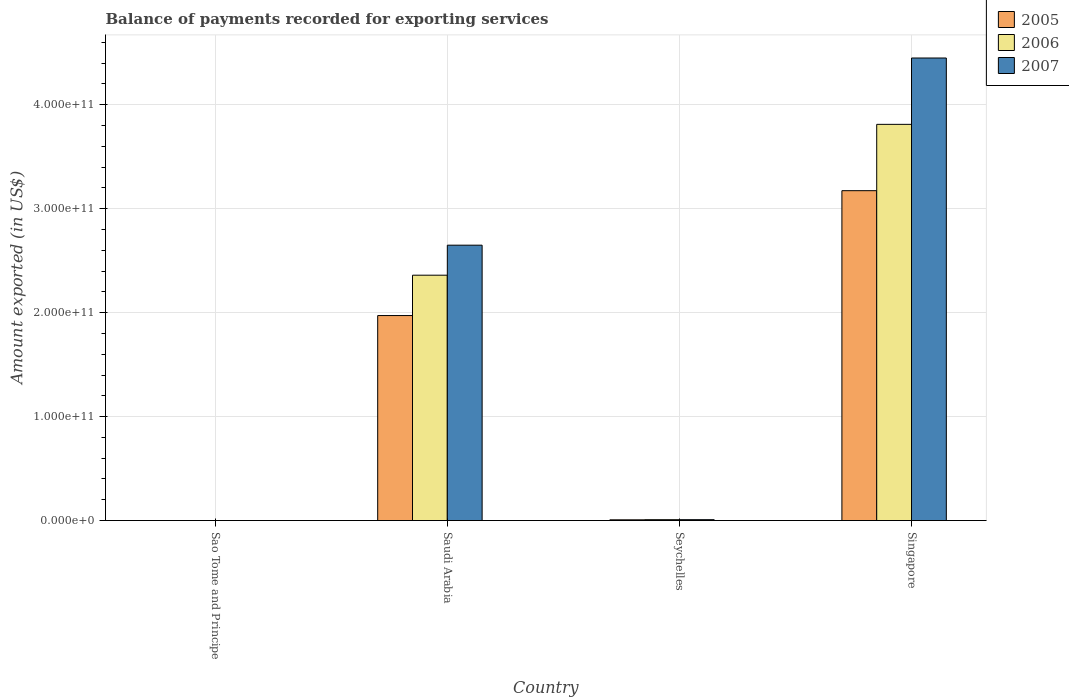How many groups of bars are there?
Give a very brief answer. 4. Are the number of bars per tick equal to the number of legend labels?
Your response must be concise. Yes. How many bars are there on the 1st tick from the left?
Offer a terse response. 3. How many bars are there on the 2nd tick from the right?
Your answer should be very brief. 3. What is the label of the 1st group of bars from the left?
Offer a terse response. Sao Tome and Principe. In how many cases, is the number of bars for a given country not equal to the number of legend labels?
Provide a short and direct response. 0. What is the amount exported in 2006 in Saudi Arabia?
Ensure brevity in your answer.  2.36e+11. Across all countries, what is the maximum amount exported in 2007?
Ensure brevity in your answer.  4.45e+11. Across all countries, what is the minimum amount exported in 2007?
Provide a short and direct response. 2.03e+07. In which country was the amount exported in 2007 maximum?
Ensure brevity in your answer.  Singapore. In which country was the amount exported in 2005 minimum?
Keep it short and to the point. Sao Tome and Principe. What is the total amount exported in 2005 in the graph?
Offer a very short reply. 5.15e+11. What is the difference between the amount exported in 2007 in Sao Tome and Principe and that in Singapore?
Your answer should be very brief. -4.45e+11. What is the difference between the amount exported in 2006 in Seychelles and the amount exported in 2005 in Saudi Arabia?
Your answer should be very brief. -1.96e+11. What is the average amount exported in 2006 per country?
Give a very brief answer. 1.54e+11. What is the difference between the amount exported of/in 2006 and amount exported of/in 2007 in Singapore?
Make the answer very short. -6.38e+1. In how many countries, is the amount exported in 2006 greater than 60000000000 US$?
Make the answer very short. 2. What is the ratio of the amount exported in 2006 in Saudi Arabia to that in Seychelles?
Offer a terse response. 274.2. What is the difference between the highest and the second highest amount exported in 2005?
Your answer should be very brief. 1.20e+11. What is the difference between the highest and the lowest amount exported in 2005?
Your response must be concise. 3.17e+11. Is the sum of the amount exported in 2007 in Sao Tome and Principe and Seychelles greater than the maximum amount exported in 2005 across all countries?
Your answer should be compact. No. Is it the case that in every country, the sum of the amount exported in 2006 and amount exported in 2007 is greater than the amount exported in 2005?
Ensure brevity in your answer.  Yes. How many bars are there?
Keep it short and to the point. 12. How many countries are there in the graph?
Give a very brief answer. 4. What is the difference between two consecutive major ticks on the Y-axis?
Keep it short and to the point. 1.00e+11. Does the graph contain any zero values?
Give a very brief answer. No. Does the graph contain grids?
Make the answer very short. Yes. What is the title of the graph?
Your answer should be compact. Balance of payments recorded for exporting services. Does "1986" appear as one of the legend labels in the graph?
Your answer should be very brief. No. What is the label or title of the X-axis?
Offer a very short reply. Country. What is the label or title of the Y-axis?
Offer a terse response. Amount exported (in US$). What is the Amount exported (in US$) of 2005 in Sao Tome and Principe?
Your response must be concise. 1.79e+07. What is the Amount exported (in US$) of 2006 in Sao Tome and Principe?
Your answer should be very brief. 2.23e+07. What is the Amount exported (in US$) in 2007 in Sao Tome and Principe?
Ensure brevity in your answer.  2.03e+07. What is the Amount exported (in US$) of 2005 in Saudi Arabia?
Provide a succinct answer. 1.97e+11. What is the Amount exported (in US$) of 2006 in Saudi Arabia?
Offer a terse response. 2.36e+11. What is the Amount exported (in US$) of 2007 in Saudi Arabia?
Your answer should be very brief. 2.65e+11. What is the Amount exported (in US$) in 2005 in Seychelles?
Provide a short and direct response. 7.29e+08. What is the Amount exported (in US$) in 2006 in Seychelles?
Ensure brevity in your answer.  8.61e+08. What is the Amount exported (in US$) in 2007 in Seychelles?
Your answer should be very brief. 8.57e+08. What is the Amount exported (in US$) of 2005 in Singapore?
Provide a short and direct response. 3.17e+11. What is the Amount exported (in US$) in 2006 in Singapore?
Your response must be concise. 3.81e+11. What is the Amount exported (in US$) of 2007 in Singapore?
Your answer should be very brief. 4.45e+11. Across all countries, what is the maximum Amount exported (in US$) in 2005?
Provide a succinct answer. 3.17e+11. Across all countries, what is the maximum Amount exported (in US$) in 2006?
Ensure brevity in your answer.  3.81e+11. Across all countries, what is the maximum Amount exported (in US$) of 2007?
Provide a short and direct response. 4.45e+11. Across all countries, what is the minimum Amount exported (in US$) in 2005?
Offer a terse response. 1.79e+07. Across all countries, what is the minimum Amount exported (in US$) of 2006?
Offer a very short reply. 2.23e+07. Across all countries, what is the minimum Amount exported (in US$) in 2007?
Give a very brief answer. 2.03e+07. What is the total Amount exported (in US$) in 2005 in the graph?
Your response must be concise. 5.15e+11. What is the total Amount exported (in US$) in 2006 in the graph?
Your answer should be compact. 6.18e+11. What is the total Amount exported (in US$) of 2007 in the graph?
Your answer should be very brief. 7.11e+11. What is the difference between the Amount exported (in US$) in 2005 in Sao Tome and Principe and that in Saudi Arabia?
Give a very brief answer. -1.97e+11. What is the difference between the Amount exported (in US$) of 2006 in Sao Tome and Principe and that in Saudi Arabia?
Make the answer very short. -2.36e+11. What is the difference between the Amount exported (in US$) in 2007 in Sao Tome and Principe and that in Saudi Arabia?
Your answer should be very brief. -2.65e+11. What is the difference between the Amount exported (in US$) of 2005 in Sao Tome and Principe and that in Seychelles?
Your answer should be compact. -7.12e+08. What is the difference between the Amount exported (in US$) of 2006 in Sao Tome and Principe and that in Seychelles?
Keep it short and to the point. -8.38e+08. What is the difference between the Amount exported (in US$) in 2007 in Sao Tome and Principe and that in Seychelles?
Provide a succinct answer. -8.37e+08. What is the difference between the Amount exported (in US$) of 2005 in Sao Tome and Principe and that in Singapore?
Provide a short and direct response. -3.17e+11. What is the difference between the Amount exported (in US$) in 2006 in Sao Tome and Principe and that in Singapore?
Keep it short and to the point. -3.81e+11. What is the difference between the Amount exported (in US$) of 2007 in Sao Tome and Principe and that in Singapore?
Provide a short and direct response. -4.45e+11. What is the difference between the Amount exported (in US$) of 2005 in Saudi Arabia and that in Seychelles?
Ensure brevity in your answer.  1.96e+11. What is the difference between the Amount exported (in US$) of 2006 in Saudi Arabia and that in Seychelles?
Offer a terse response. 2.35e+11. What is the difference between the Amount exported (in US$) in 2007 in Saudi Arabia and that in Seychelles?
Your answer should be compact. 2.64e+11. What is the difference between the Amount exported (in US$) of 2005 in Saudi Arabia and that in Singapore?
Your answer should be very brief. -1.20e+11. What is the difference between the Amount exported (in US$) of 2006 in Saudi Arabia and that in Singapore?
Keep it short and to the point. -1.45e+11. What is the difference between the Amount exported (in US$) in 2007 in Saudi Arabia and that in Singapore?
Give a very brief answer. -1.80e+11. What is the difference between the Amount exported (in US$) in 2005 in Seychelles and that in Singapore?
Provide a succinct answer. -3.17e+11. What is the difference between the Amount exported (in US$) of 2006 in Seychelles and that in Singapore?
Your answer should be compact. -3.80e+11. What is the difference between the Amount exported (in US$) in 2007 in Seychelles and that in Singapore?
Offer a very short reply. -4.44e+11. What is the difference between the Amount exported (in US$) in 2005 in Sao Tome and Principe and the Amount exported (in US$) in 2006 in Saudi Arabia?
Provide a succinct answer. -2.36e+11. What is the difference between the Amount exported (in US$) of 2005 in Sao Tome and Principe and the Amount exported (in US$) of 2007 in Saudi Arabia?
Your answer should be very brief. -2.65e+11. What is the difference between the Amount exported (in US$) in 2006 in Sao Tome and Principe and the Amount exported (in US$) in 2007 in Saudi Arabia?
Offer a very short reply. -2.65e+11. What is the difference between the Amount exported (in US$) of 2005 in Sao Tome and Principe and the Amount exported (in US$) of 2006 in Seychelles?
Offer a terse response. -8.43e+08. What is the difference between the Amount exported (in US$) of 2005 in Sao Tome and Principe and the Amount exported (in US$) of 2007 in Seychelles?
Ensure brevity in your answer.  -8.39e+08. What is the difference between the Amount exported (in US$) of 2006 in Sao Tome and Principe and the Amount exported (in US$) of 2007 in Seychelles?
Ensure brevity in your answer.  -8.35e+08. What is the difference between the Amount exported (in US$) of 2005 in Sao Tome and Principe and the Amount exported (in US$) of 2006 in Singapore?
Provide a succinct answer. -3.81e+11. What is the difference between the Amount exported (in US$) of 2005 in Sao Tome and Principe and the Amount exported (in US$) of 2007 in Singapore?
Give a very brief answer. -4.45e+11. What is the difference between the Amount exported (in US$) of 2006 in Sao Tome and Principe and the Amount exported (in US$) of 2007 in Singapore?
Give a very brief answer. -4.45e+11. What is the difference between the Amount exported (in US$) in 2005 in Saudi Arabia and the Amount exported (in US$) in 2006 in Seychelles?
Offer a very short reply. 1.96e+11. What is the difference between the Amount exported (in US$) in 2005 in Saudi Arabia and the Amount exported (in US$) in 2007 in Seychelles?
Your response must be concise. 1.96e+11. What is the difference between the Amount exported (in US$) of 2006 in Saudi Arabia and the Amount exported (in US$) of 2007 in Seychelles?
Offer a terse response. 2.35e+11. What is the difference between the Amount exported (in US$) in 2005 in Saudi Arabia and the Amount exported (in US$) in 2006 in Singapore?
Make the answer very short. -1.84e+11. What is the difference between the Amount exported (in US$) of 2005 in Saudi Arabia and the Amount exported (in US$) of 2007 in Singapore?
Offer a very short reply. -2.48e+11. What is the difference between the Amount exported (in US$) in 2006 in Saudi Arabia and the Amount exported (in US$) in 2007 in Singapore?
Offer a terse response. -2.09e+11. What is the difference between the Amount exported (in US$) of 2005 in Seychelles and the Amount exported (in US$) of 2006 in Singapore?
Give a very brief answer. -3.80e+11. What is the difference between the Amount exported (in US$) of 2005 in Seychelles and the Amount exported (in US$) of 2007 in Singapore?
Ensure brevity in your answer.  -4.44e+11. What is the difference between the Amount exported (in US$) in 2006 in Seychelles and the Amount exported (in US$) in 2007 in Singapore?
Ensure brevity in your answer.  -4.44e+11. What is the average Amount exported (in US$) of 2005 per country?
Keep it short and to the point. 1.29e+11. What is the average Amount exported (in US$) of 2006 per country?
Offer a terse response. 1.54e+11. What is the average Amount exported (in US$) of 2007 per country?
Keep it short and to the point. 1.78e+11. What is the difference between the Amount exported (in US$) in 2005 and Amount exported (in US$) in 2006 in Sao Tome and Principe?
Offer a very short reply. -4.35e+06. What is the difference between the Amount exported (in US$) of 2005 and Amount exported (in US$) of 2007 in Sao Tome and Principe?
Keep it short and to the point. -2.36e+06. What is the difference between the Amount exported (in US$) in 2006 and Amount exported (in US$) in 2007 in Sao Tome and Principe?
Ensure brevity in your answer.  1.99e+06. What is the difference between the Amount exported (in US$) in 2005 and Amount exported (in US$) in 2006 in Saudi Arabia?
Provide a succinct answer. -3.88e+1. What is the difference between the Amount exported (in US$) of 2005 and Amount exported (in US$) of 2007 in Saudi Arabia?
Offer a terse response. -6.77e+1. What is the difference between the Amount exported (in US$) in 2006 and Amount exported (in US$) in 2007 in Saudi Arabia?
Offer a very short reply. -2.89e+1. What is the difference between the Amount exported (in US$) of 2005 and Amount exported (in US$) of 2006 in Seychelles?
Provide a succinct answer. -1.31e+08. What is the difference between the Amount exported (in US$) of 2005 and Amount exported (in US$) of 2007 in Seychelles?
Give a very brief answer. -1.28e+08. What is the difference between the Amount exported (in US$) of 2006 and Amount exported (in US$) of 2007 in Seychelles?
Your answer should be very brief. 3.32e+06. What is the difference between the Amount exported (in US$) of 2005 and Amount exported (in US$) of 2006 in Singapore?
Provide a succinct answer. -6.38e+1. What is the difference between the Amount exported (in US$) in 2005 and Amount exported (in US$) in 2007 in Singapore?
Your answer should be compact. -1.28e+11. What is the difference between the Amount exported (in US$) of 2006 and Amount exported (in US$) of 2007 in Singapore?
Your answer should be compact. -6.38e+1. What is the ratio of the Amount exported (in US$) of 2005 in Sao Tome and Principe to that in Seychelles?
Provide a short and direct response. 0.02. What is the ratio of the Amount exported (in US$) in 2006 in Sao Tome and Principe to that in Seychelles?
Make the answer very short. 0.03. What is the ratio of the Amount exported (in US$) of 2007 in Sao Tome and Principe to that in Seychelles?
Make the answer very short. 0.02. What is the ratio of the Amount exported (in US$) in 2005 in Sao Tome and Principe to that in Singapore?
Provide a short and direct response. 0. What is the ratio of the Amount exported (in US$) of 2007 in Sao Tome and Principe to that in Singapore?
Give a very brief answer. 0. What is the ratio of the Amount exported (in US$) of 2005 in Saudi Arabia to that in Seychelles?
Provide a succinct answer. 270.3. What is the ratio of the Amount exported (in US$) in 2006 in Saudi Arabia to that in Seychelles?
Provide a succinct answer. 274.2. What is the ratio of the Amount exported (in US$) in 2007 in Saudi Arabia to that in Seychelles?
Give a very brief answer. 308.93. What is the ratio of the Amount exported (in US$) of 2005 in Saudi Arabia to that in Singapore?
Make the answer very short. 0.62. What is the ratio of the Amount exported (in US$) in 2006 in Saudi Arabia to that in Singapore?
Keep it short and to the point. 0.62. What is the ratio of the Amount exported (in US$) of 2007 in Saudi Arabia to that in Singapore?
Provide a short and direct response. 0.6. What is the ratio of the Amount exported (in US$) of 2005 in Seychelles to that in Singapore?
Your response must be concise. 0. What is the ratio of the Amount exported (in US$) in 2006 in Seychelles to that in Singapore?
Ensure brevity in your answer.  0. What is the ratio of the Amount exported (in US$) of 2007 in Seychelles to that in Singapore?
Your answer should be compact. 0. What is the difference between the highest and the second highest Amount exported (in US$) in 2005?
Give a very brief answer. 1.20e+11. What is the difference between the highest and the second highest Amount exported (in US$) of 2006?
Provide a succinct answer. 1.45e+11. What is the difference between the highest and the second highest Amount exported (in US$) of 2007?
Offer a terse response. 1.80e+11. What is the difference between the highest and the lowest Amount exported (in US$) of 2005?
Your response must be concise. 3.17e+11. What is the difference between the highest and the lowest Amount exported (in US$) of 2006?
Your answer should be compact. 3.81e+11. What is the difference between the highest and the lowest Amount exported (in US$) of 2007?
Your answer should be very brief. 4.45e+11. 